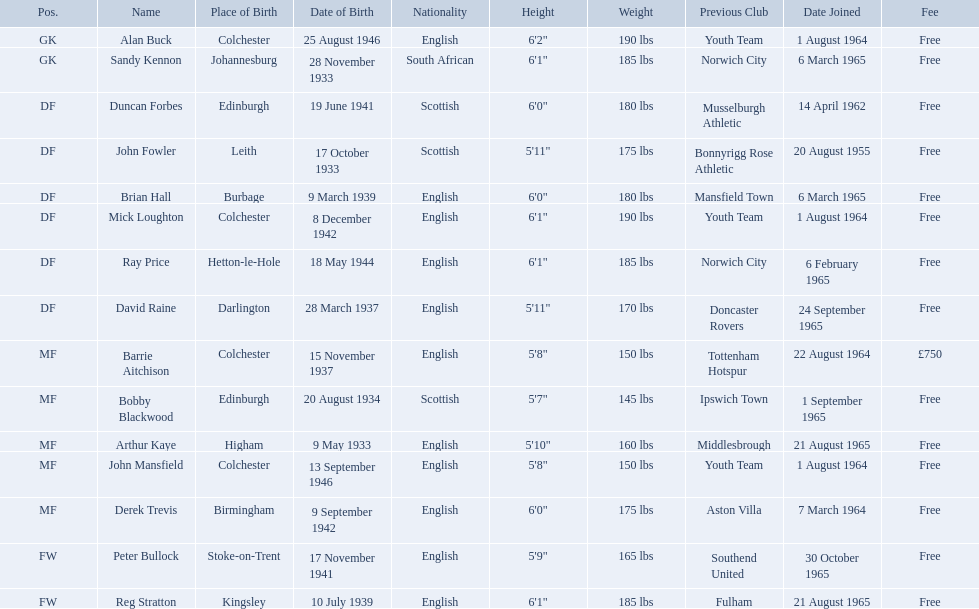When did alan buck join the colchester united f.c. in 1965-66? 1 August 1964. When did the last player to join? Peter Bullock. What date did the first player join? 20 August 1955. Who are all the players? Alan Buck, Sandy Kennon, Duncan Forbes, John Fowler, Brian Hall, Mick Loughton, Ray Price, David Raine, Barrie Aitchison, Bobby Blackwood, Arthur Kaye, John Mansfield, Derek Trevis, Peter Bullock, Reg Stratton. What dates did the players join on? 1 August 1964, 6 March 1965, 14 April 1962, 20 August 1955, 6 March 1965, 1 August 1964, 6 February 1965, 24 September 1965, 22 August 1964, 1 September 1965, 21 August 1965, 1 August 1964, 7 March 1964, 30 October 1965, 21 August 1965. Who is the first player who joined? John Fowler. What is the date of the first person who joined? 20 August 1955. 